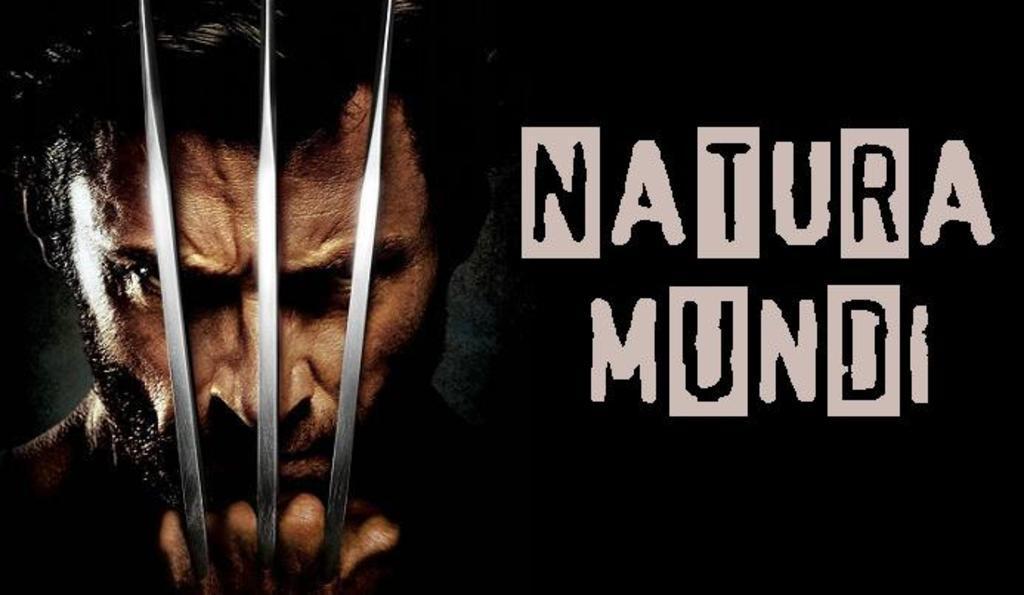In one or two sentences, can you explain what this image depicts? In this picture we can see some text, a person and a few objects on the left side. We can see the dark view in the background. 